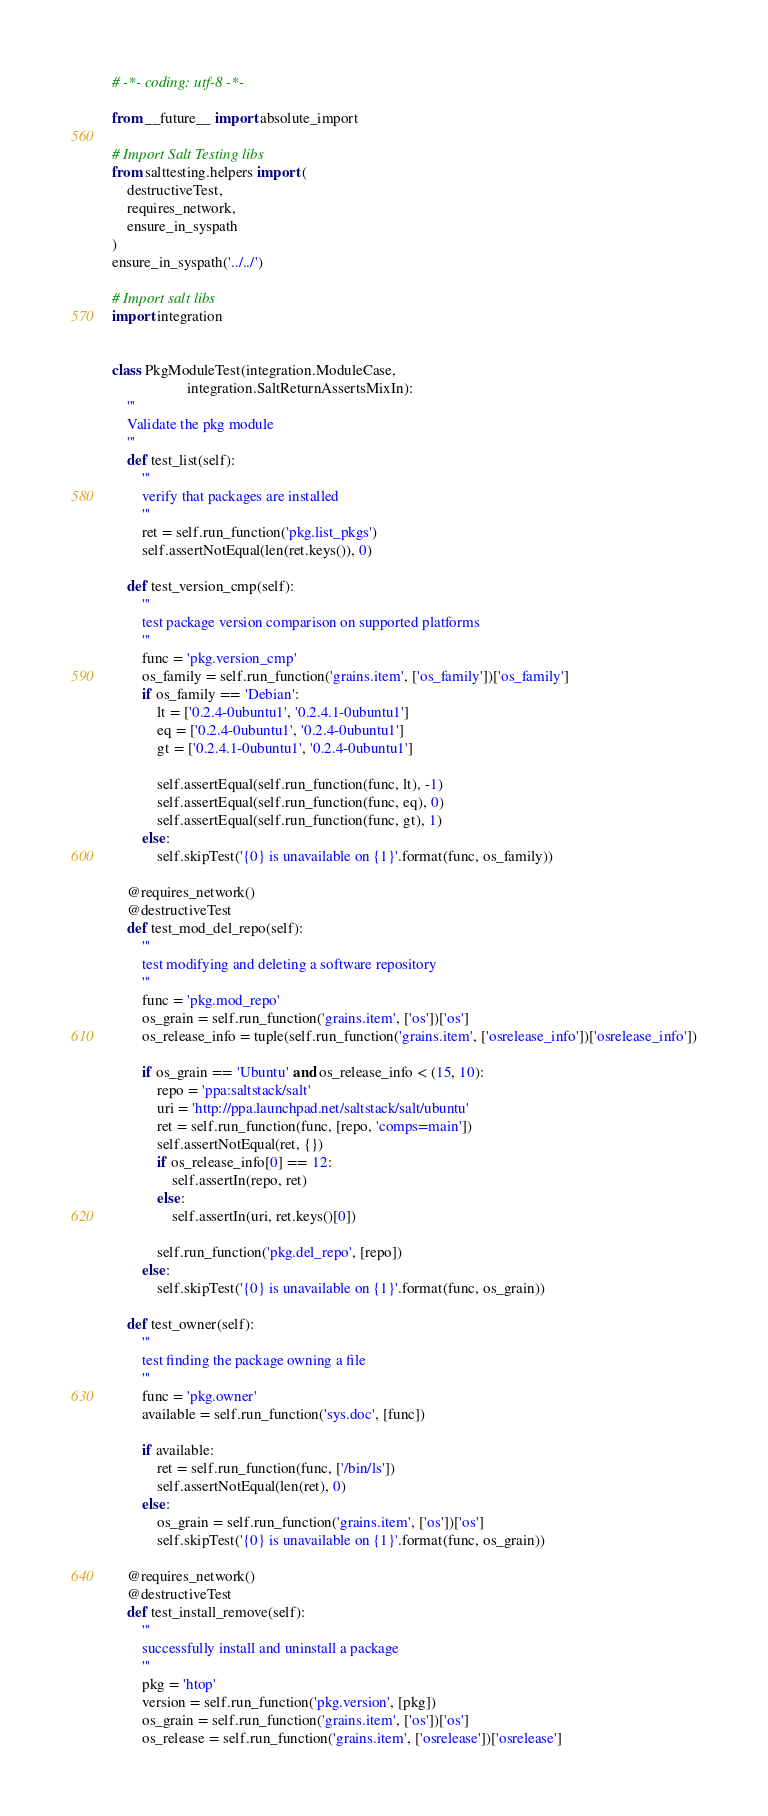Convert code to text. <code><loc_0><loc_0><loc_500><loc_500><_Python_># -*- coding: utf-8 -*-

from __future__ import absolute_import

# Import Salt Testing libs
from salttesting.helpers import (
    destructiveTest,
    requires_network,
    ensure_in_syspath
)
ensure_in_syspath('../../')

# Import salt libs
import integration


class PkgModuleTest(integration.ModuleCase,
                    integration.SaltReturnAssertsMixIn):
    '''
    Validate the pkg module
    '''
    def test_list(self):
        '''
        verify that packages are installed
        '''
        ret = self.run_function('pkg.list_pkgs')
        self.assertNotEqual(len(ret.keys()), 0)

    def test_version_cmp(self):
        '''
        test package version comparison on supported platforms
        '''
        func = 'pkg.version_cmp'
        os_family = self.run_function('grains.item', ['os_family'])['os_family']
        if os_family == 'Debian':
            lt = ['0.2.4-0ubuntu1', '0.2.4.1-0ubuntu1']
            eq = ['0.2.4-0ubuntu1', '0.2.4-0ubuntu1']
            gt = ['0.2.4.1-0ubuntu1', '0.2.4-0ubuntu1']

            self.assertEqual(self.run_function(func, lt), -1)
            self.assertEqual(self.run_function(func, eq), 0)
            self.assertEqual(self.run_function(func, gt), 1)
        else:
            self.skipTest('{0} is unavailable on {1}'.format(func, os_family))

    @requires_network()
    @destructiveTest
    def test_mod_del_repo(self):
        '''
        test modifying and deleting a software repository
        '''
        func = 'pkg.mod_repo'
        os_grain = self.run_function('grains.item', ['os'])['os']
        os_release_info = tuple(self.run_function('grains.item', ['osrelease_info'])['osrelease_info'])

        if os_grain == 'Ubuntu' and os_release_info < (15, 10):
            repo = 'ppa:saltstack/salt'
            uri = 'http://ppa.launchpad.net/saltstack/salt/ubuntu'
            ret = self.run_function(func, [repo, 'comps=main'])
            self.assertNotEqual(ret, {})
            if os_release_info[0] == 12:
                self.assertIn(repo, ret)
            else:
                self.assertIn(uri, ret.keys()[0])

            self.run_function('pkg.del_repo', [repo])
        else:
            self.skipTest('{0} is unavailable on {1}'.format(func, os_grain))

    def test_owner(self):
        '''
        test finding the package owning a file
        '''
        func = 'pkg.owner'
        available = self.run_function('sys.doc', [func])

        if available:
            ret = self.run_function(func, ['/bin/ls'])
            self.assertNotEqual(len(ret), 0)
        else:
            os_grain = self.run_function('grains.item', ['os'])['os']
            self.skipTest('{0} is unavailable on {1}'.format(func, os_grain))

    @requires_network()
    @destructiveTest
    def test_install_remove(self):
        '''
        successfully install and uninstall a package
        '''
        pkg = 'htop'
        version = self.run_function('pkg.version', [pkg])
        os_grain = self.run_function('grains.item', ['os'])['os']
        os_release = self.run_function('grains.item', ['osrelease'])['osrelease']
</code> 